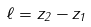Convert formula to latex. <formula><loc_0><loc_0><loc_500><loc_500>\ell = z _ { 2 } - z _ { 1 }</formula> 